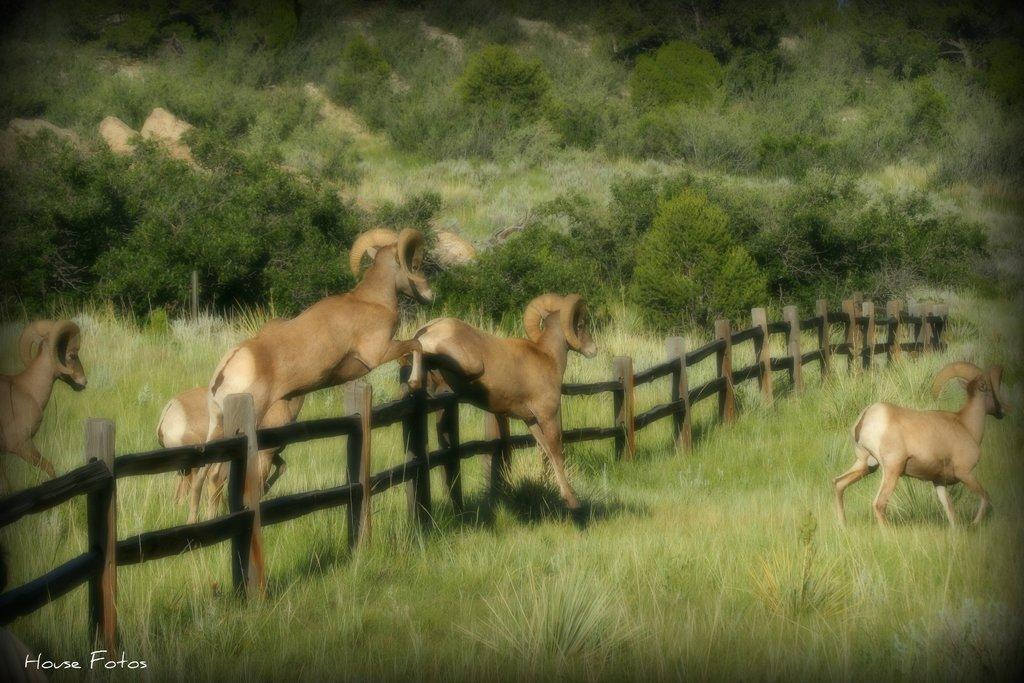What type of vegetation can be seen in the image? There are many trees and plants in the image. What is the terrain like in the image? There is a grassy land in the image. Are there any animals present in the image? Yes, there are animals in the image. What kind of barrier can be seen in the image? There is a fencing in the image. What month is depicted in the image? The image does not depict a specific month; it shows a natural landscape with trees, plants, grassy land, animals, and fencing. 